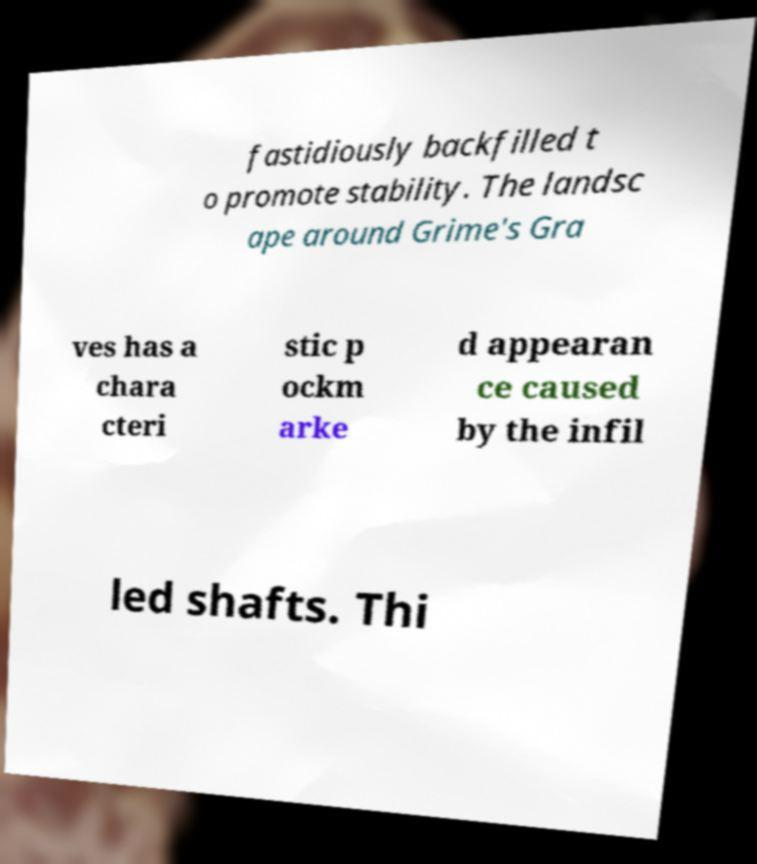There's text embedded in this image that I need extracted. Can you transcribe it verbatim? fastidiously backfilled t o promote stability. The landsc ape around Grime's Gra ves has a chara cteri stic p ockm arke d appearan ce caused by the infil led shafts. Thi 